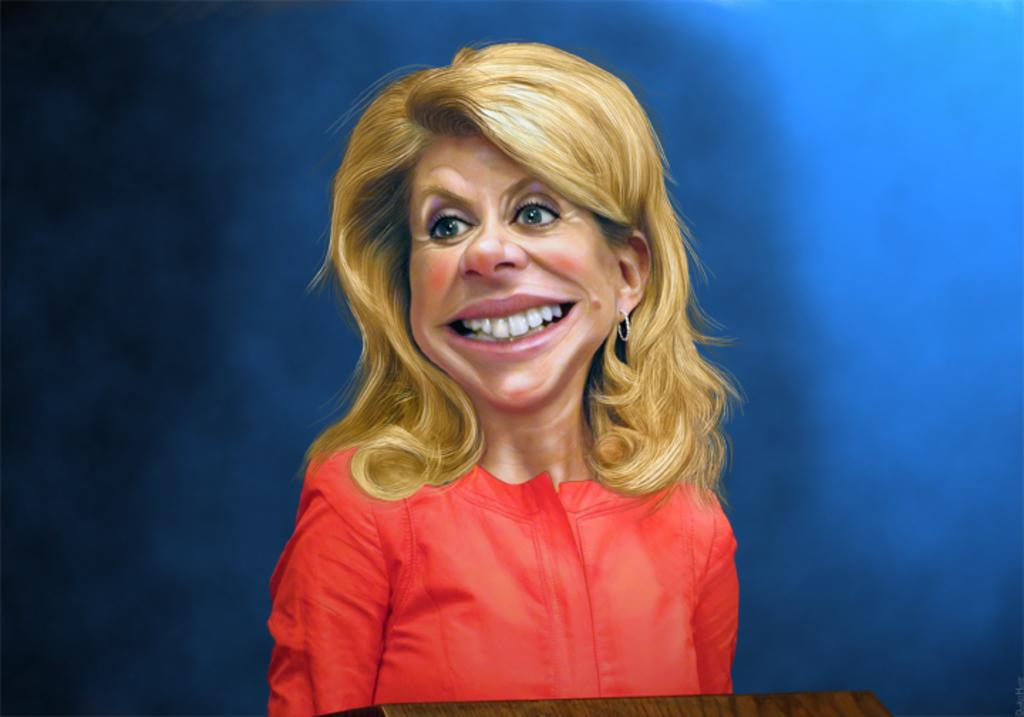What is the dog playing with in the image? The dog is playing with a ball in the image. What color is the ball that the dog is playing with? The ball is yellow. Where is the quiver located in the image? There is no quiver present in the image. What type of throne is depicted in the image? There is no throne present in the image. 